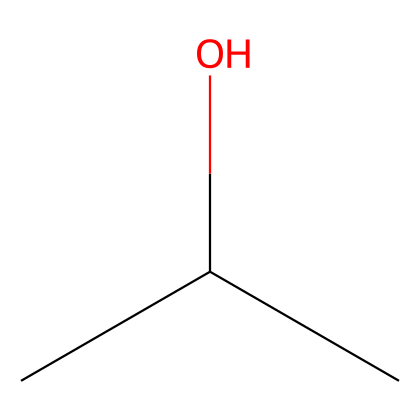What is the name of this chemical? The provided SMILES representation (CC(C)O) corresponds to isopropyl alcohol, which is a common name for the compound with this structure.
Answer: isopropyl alcohol How many carbon atoms are present in this structure? The SMILES shows three carbon atoms (the 'C' characters), indicating that isopropyl alcohol consists of three carbons in its structure.
Answer: 3 What functional group is present in isopropyl alcohol? The molecule contains a hydroxyl group (-OH) attached to one of the carbon atoms (the 'O' in the structure), identifying it as an alcohol.
Answer: hydroxyl What type of solvent is isopropyl alcohol? Isopropyl alcohol is classified as a polar solvent because it has a hydroxyl group which allows it to interact with water and dissolve other polar substances.
Answer: polar solvent What is the molecular formula of isopropyl alcohol? The molecular formula can be derived from the SMILES representation, indicating 3 carbon atoms, 8 hydrogen atoms, and 1 oxygen atom, giving the formula C3H8O.
Answer: C3H8O Does isopropyl alcohol have antibacterial properties? Isopropyl alcohol is known to have antibacterial properties, making it effective for cleaning surfaces and equipment to eliminate germs.
Answer: yes How many hydrogen atoms are connected to the carbon atoms? Each carbon in isopropyl alcohol is bonded to a sufficient number of hydrogen atoms to satisfy the tetravalency of carbon. In total, there are 8 hydrogen atoms.
Answer: 8 